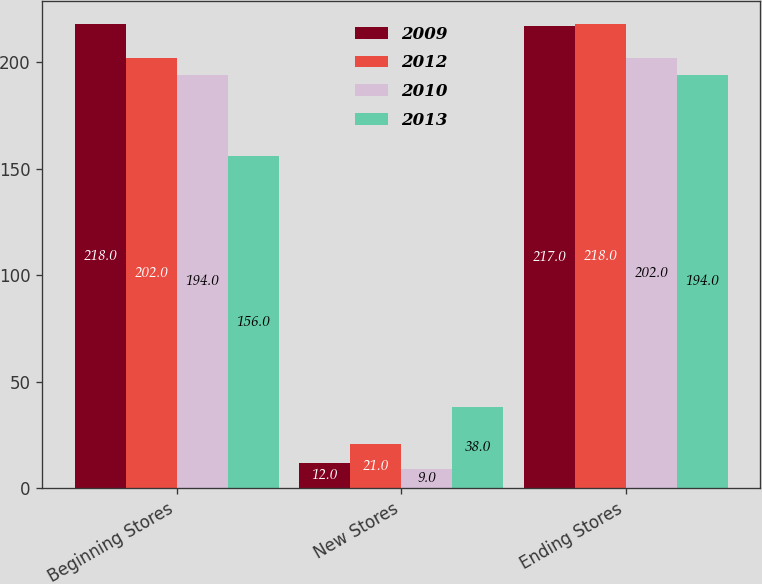Convert chart. <chart><loc_0><loc_0><loc_500><loc_500><stacked_bar_chart><ecel><fcel>Beginning Stores<fcel>New Stores<fcel>Ending Stores<nl><fcel>2009<fcel>218<fcel>12<fcel>217<nl><fcel>2012<fcel>202<fcel>21<fcel>218<nl><fcel>2010<fcel>194<fcel>9<fcel>202<nl><fcel>2013<fcel>156<fcel>38<fcel>194<nl></chart> 